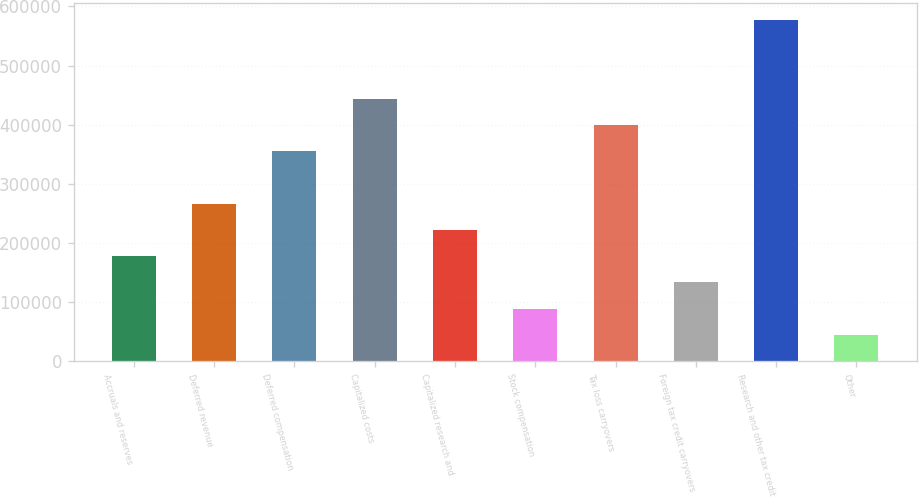Convert chart. <chart><loc_0><loc_0><loc_500><loc_500><bar_chart><fcel>Accruals and reserves<fcel>Deferred revenue<fcel>Deferred compensation<fcel>Capitalized costs<fcel>Capitalized research and<fcel>Stock compensation<fcel>Tax loss carryovers<fcel>Foreign tax credit carryovers<fcel>Research and other tax credit<fcel>Other<nl><fcel>178109<fcel>266800<fcel>355492<fcel>444183<fcel>222454<fcel>89417.4<fcel>399837<fcel>133763<fcel>577220<fcel>45071.7<nl></chart> 